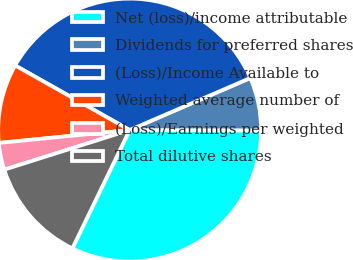<chart> <loc_0><loc_0><loc_500><loc_500><pie_chart><fcel>Net (loss)/income attributable<fcel>Dividends for preferred shares<fcel>(Loss)/Income Available to<fcel>Weighted average number of<fcel>(Loss)/Earnings per weighted<fcel>Total dilutive shares<nl><fcel>32.13%<fcel>6.52%<fcel>35.34%<fcel>9.74%<fcel>3.31%<fcel>12.95%<nl></chart> 